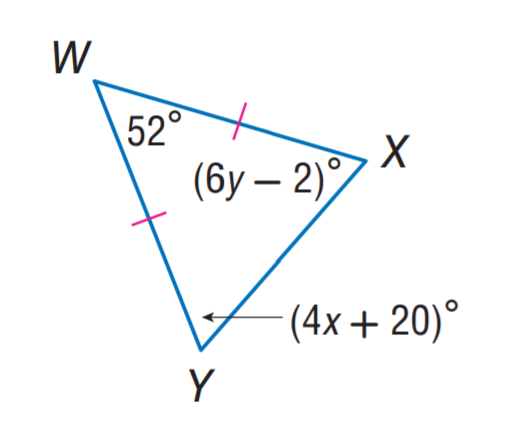Answer the mathemtical geometry problem and directly provide the correct option letter.
Question: Find y.
Choices: A: 9 B: 11 C: 12 D: 20 B 